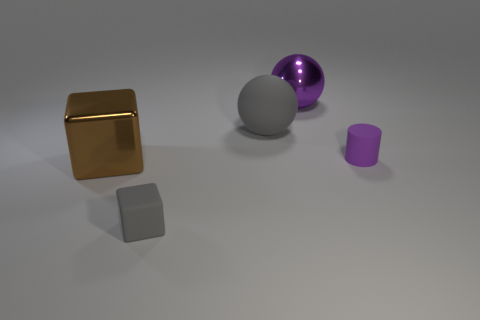What number of shiny objects are either brown balls or big purple balls?
Offer a terse response. 1. Are there an equal number of small rubber things that are behind the big brown block and big purple balls?
Ensure brevity in your answer.  Yes. There is a shiny object left of the large metal sphere; does it have the same color as the big metallic sphere?
Provide a short and direct response. No. There is a thing that is in front of the large gray matte thing and on the right side of the gray sphere; what material is it?
Your answer should be compact. Rubber. There is a gray rubber object in front of the gray sphere; are there any gray matte objects left of it?
Ensure brevity in your answer.  No. Does the tiny cube have the same material as the brown thing?
Offer a terse response. No. What is the shape of the object that is both in front of the purple cylinder and behind the tiny gray rubber thing?
Your answer should be very brief. Cube. There is a gray thing behind the cube right of the shiny cube; what size is it?
Offer a terse response. Large. What number of red matte objects have the same shape as the big purple thing?
Your answer should be very brief. 0. Is the color of the small cylinder the same as the rubber ball?
Offer a very short reply. No. 